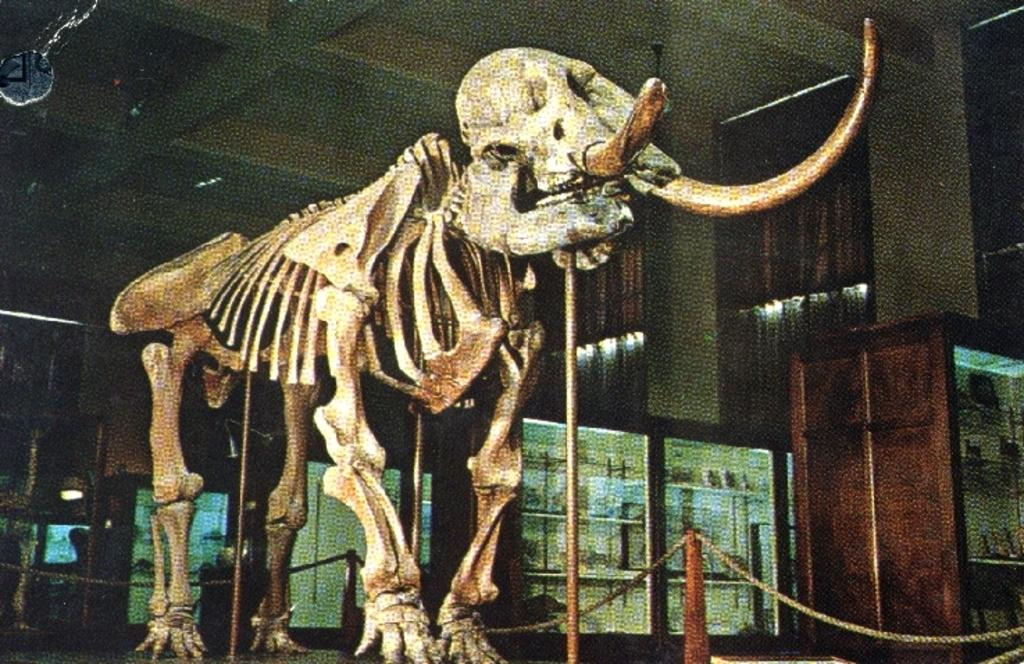What is the main subject in the center of the image? There is an elephant skeleton in the center of the image. What can be seen in the background of the image? There is a wall, a roof, lights, pillars, racks, and a few other objects in the background of the image. What degree does the elephant have in the image? There is no indication of the elephant having a degree in the image, as it is a skeleton and not a living being. 